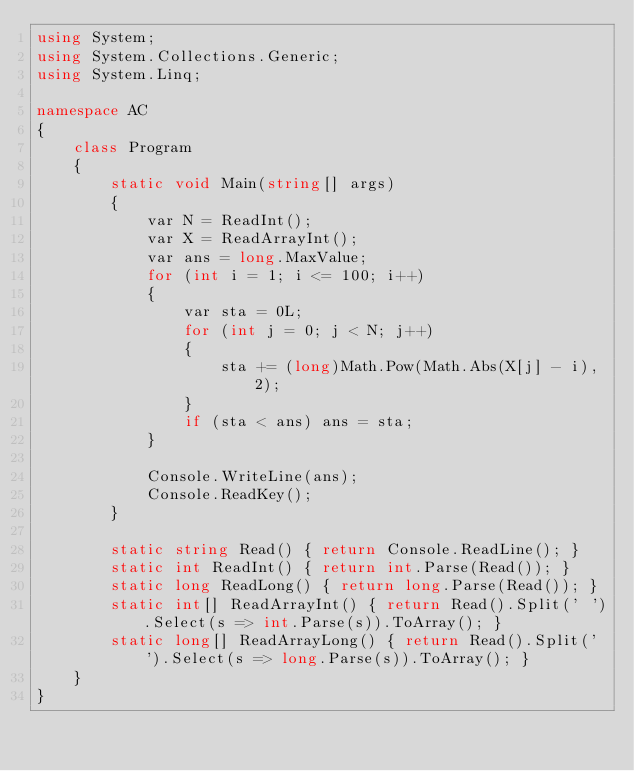<code> <loc_0><loc_0><loc_500><loc_500><_C#_>using System;
using System.Collections.Generic;
using System.Linq;

namespace AC
{
    class Program
    {
        static void Main(string[] args)
        {
            var N = ReadInt();
            var X = ReadArrayInt();
            var ans = long.MaxValue;
            for (int i = 1; i <= 100; i++)
            {
                var sta = 0L;
                for (int j = 0; j < N; j++)
                {
                    sta += (long)Math.Pow(Math.Abs(X[j] - i), 2);
                }
                if (sta < ans) ans = sta;
            }

            Console.WriteLine(ans);
            Console.ReadKey();
        }

        static string Read() { return Console.ReadLine(); }
        static int ReadInt() { return int.Parse(Read()); }
        static long ReadLong() { return long.Parse(Read()); }
        static int[] ReadArrayInt() { return Read().Split(' ').Select(s => int.Parse(s)).ToArray(); }
        static long[] ReadArrayLong() { return Read().Split(' ').Select(s => long.Parse(s)).ToArray(); }
    }
}</code> 